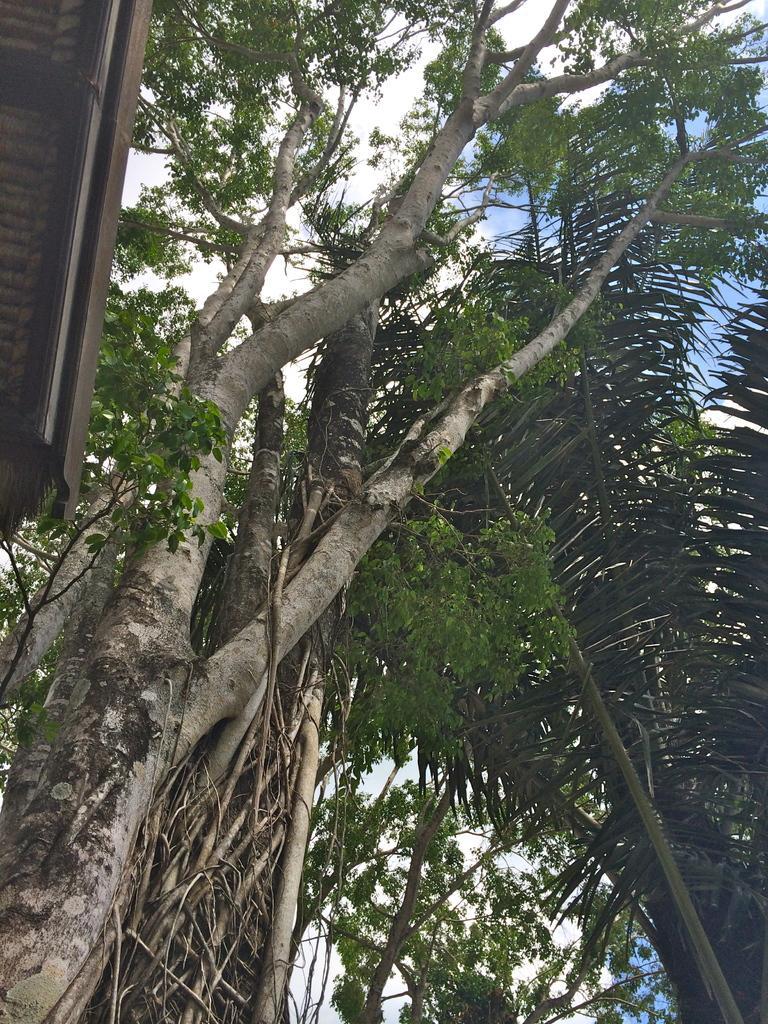In one or two sentences, can you explain what this image depicts? In this picture we can see many trees. On the left there is a shed. At the top we can see sky and clouds. 